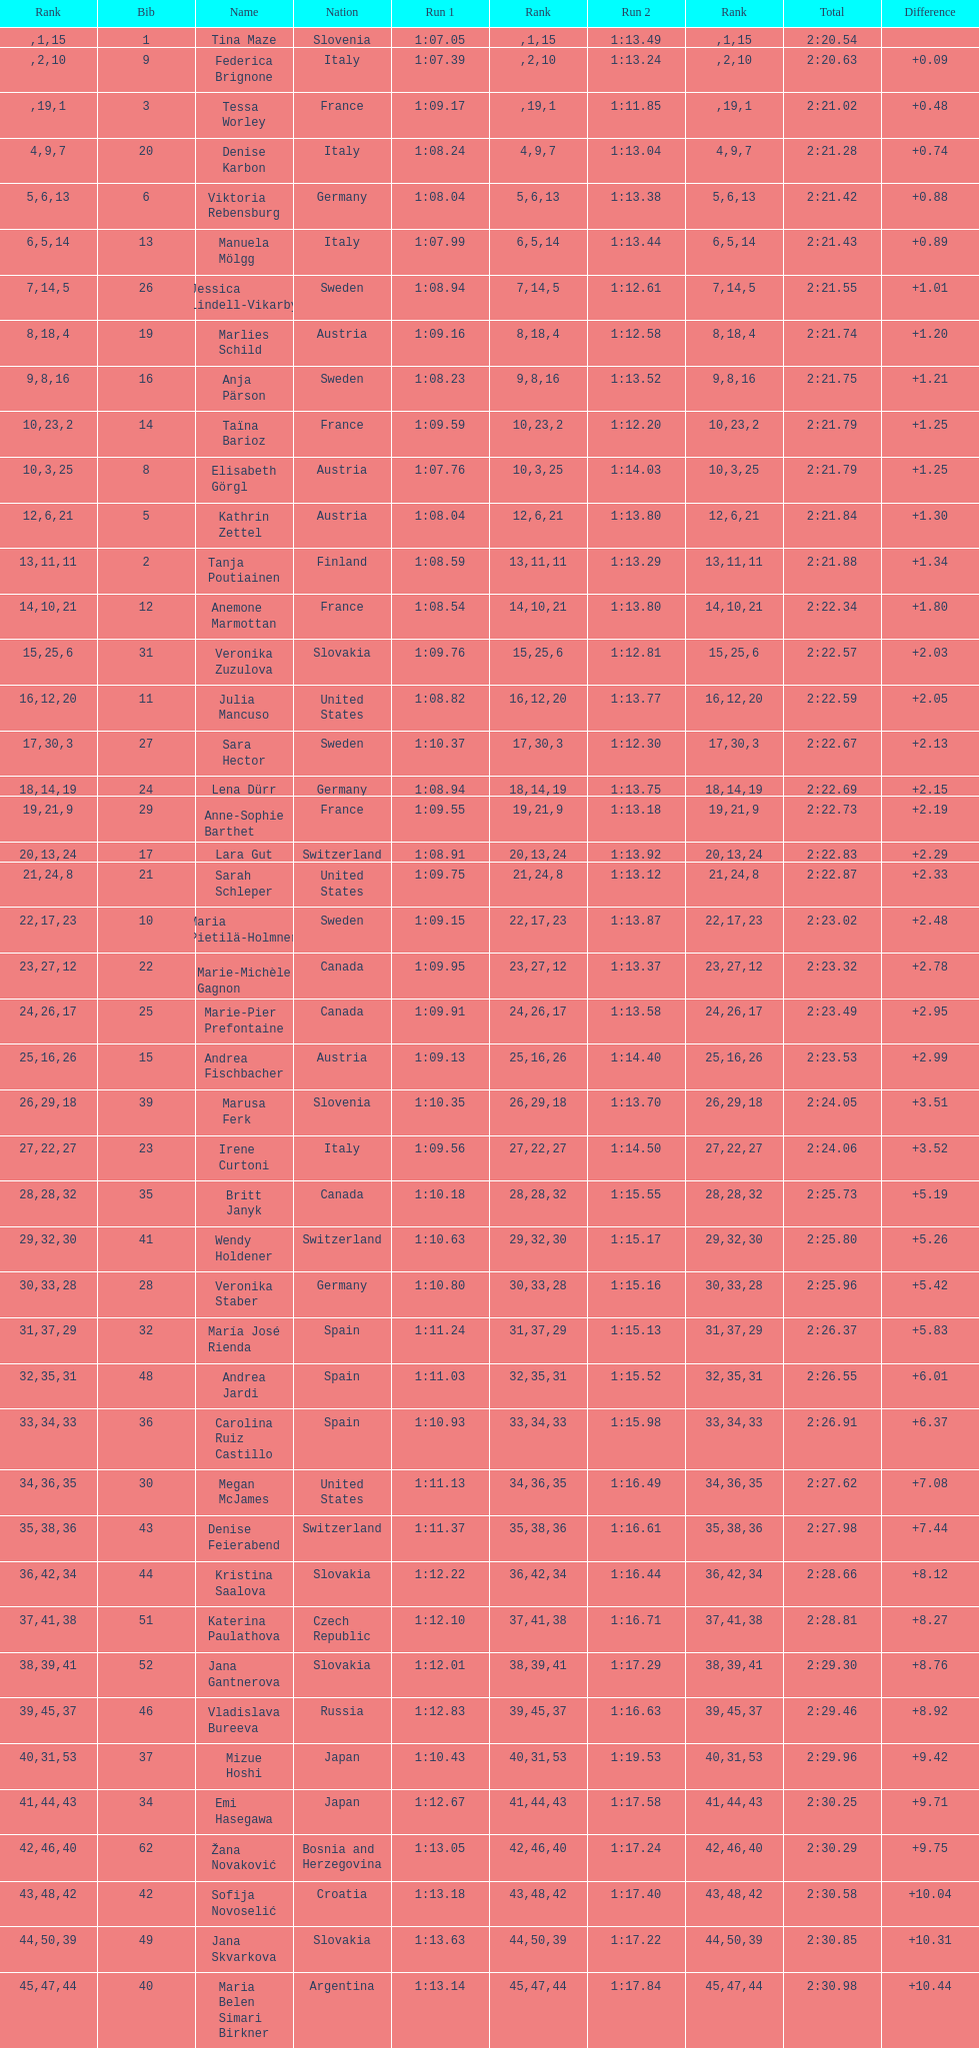What is the last country to receive a ranking? Czech Republic. 